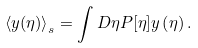Convert formula to latex. <formula><loc_0><loc_0><loc_500><loc_500>\left \langle y ( \eta ) \right \rangle _ { s } = \int D \eta P [ \eta ] y \left ( \eta \right ) .</formula> 